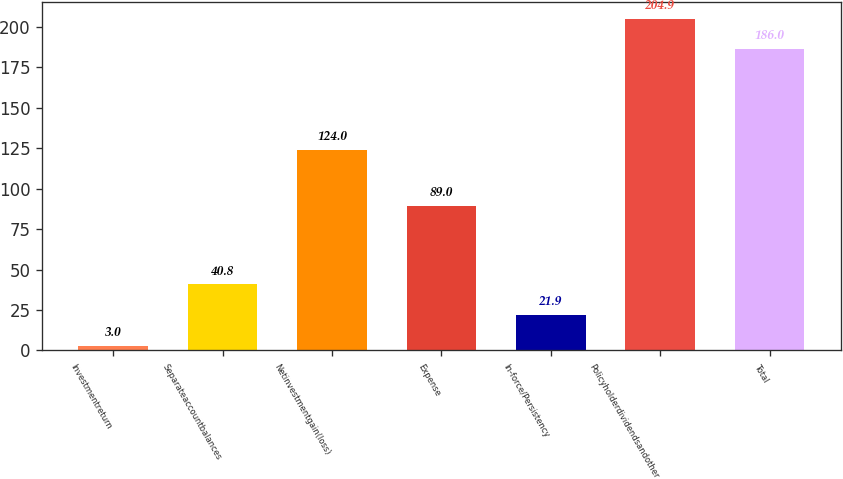<chart> <loc_0><loc_0><loc_500><loc_500><bar_chart><fcel>Investmentreturn<fcel>Separateaccountbalances<fcel>Netinvestmentgain(loss)<fcel>Expense<fcel>In-force/Persistency<fcel>Policyholderdividendsandother<fcel>Total<nl><fcel>3<fcel>40.8<fcel>124<fcel>89<fcel>21.9<fcel>204.9<fcel>186<nl></chart> 